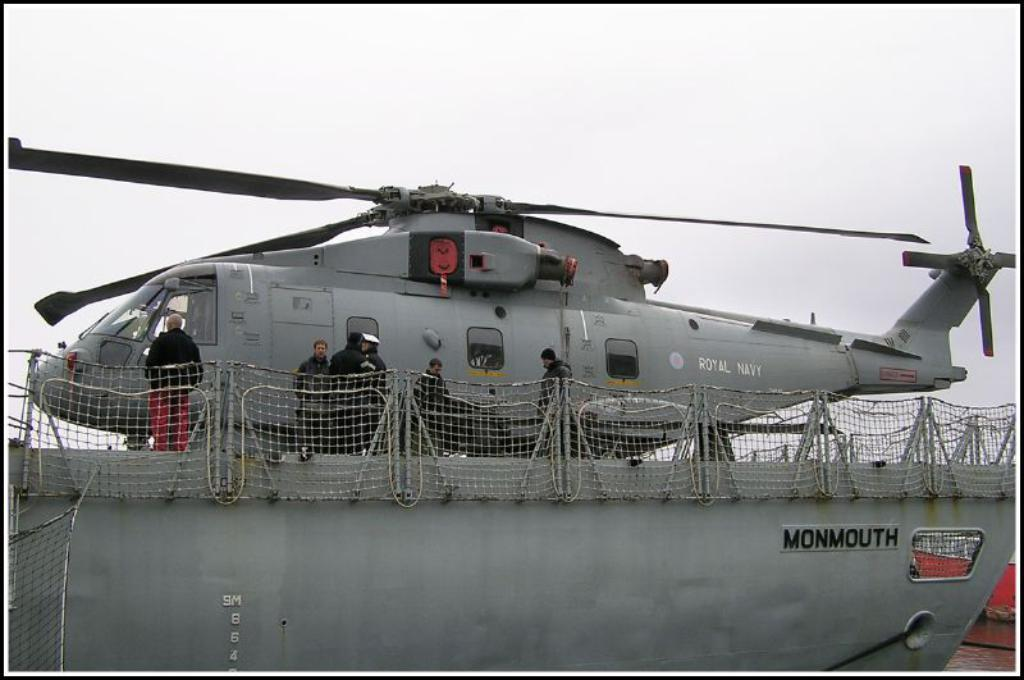<image>
Describe the image concisely. A Monmouth ship is carrying a helicopter on top of it. 